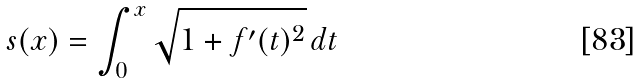<formula> <loc_0><loc_0><loc_500><loc_500>s ( x ) = \int _ { 0 } ^ { x } \sqrt { 1 + f ^ { \prime } ( t ) ^ { 2 } } \, d t</formula> 